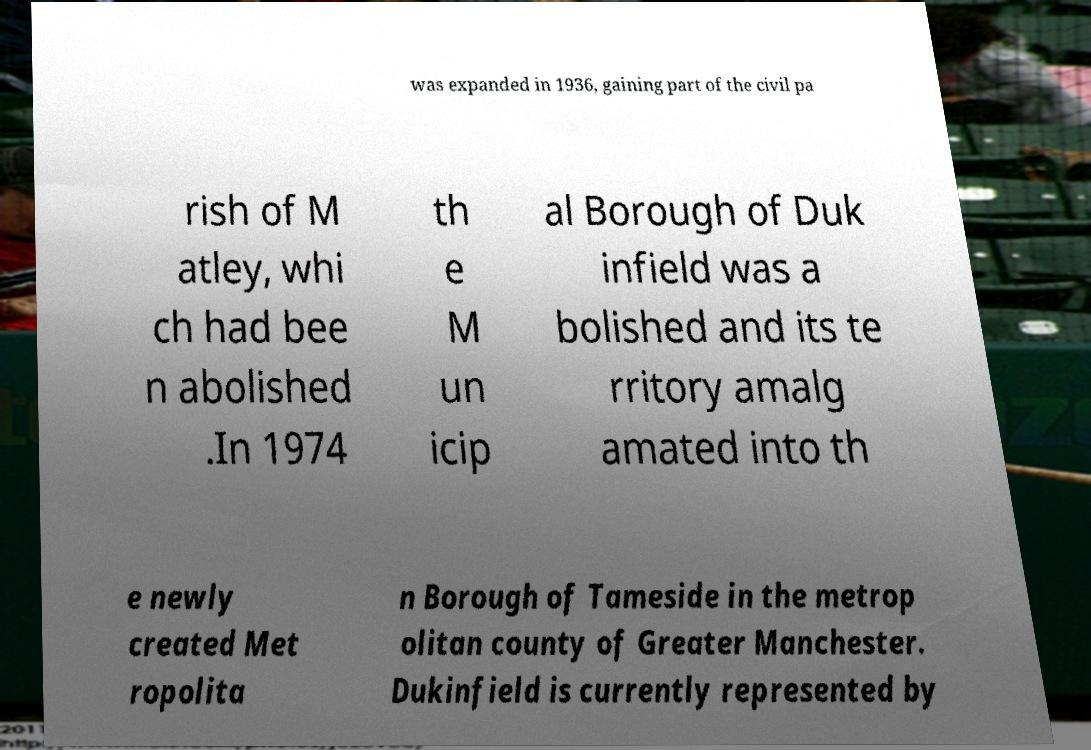I need the written content from this picture converted into text. Can you do that? was expanded in 1936, gaining part of the civil pa rish of M atley, whi ch had bee n abolished .In 1974 th e M un icip al Borough of Duk infield was a bolished and its te rritory amalg amated into th e newly created Met ropolita n Borough of Tameside in the metrop olitan county of Greater Manchester. Dukinfield is currently represented by 